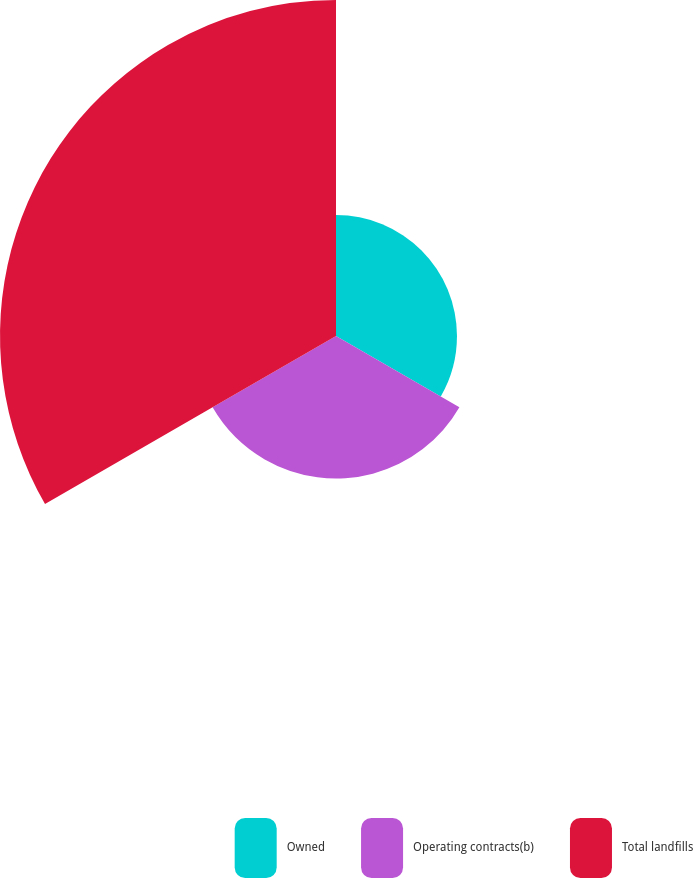Convert chart to OTSL. <chart><loc_0><loc_0><loc_500><loc_500><pie_chart><fcel>Owned<fcel>Operating contracts(b)<fcel>Total landfills<nl><fcel>20.18%<fcel>23.77%<fcel>56.05%<nl></chart> 